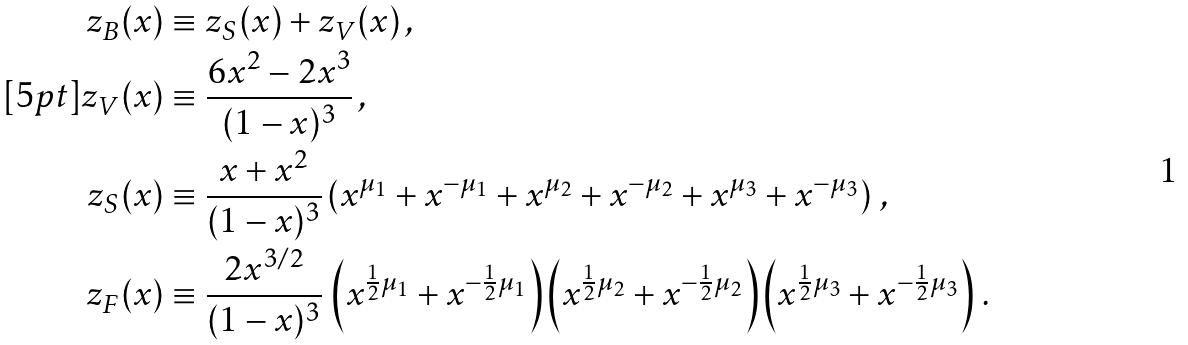Convert formula to latex. <formula><loc_0><loc_0><loc_500><loc_500>z _ { B } ( x ) & \equiv z _ { S } ( x ) + z _ { V } ( x ) \, , \\ [ 5 p t ] z _ { V } ( x ) & \equiv \frac { 6 x ^ { 2 } - 2 x ^ { 3 } } { ( 1 - x ) ^ { 3 } } \, , \\ z _ { S } ( x ) & \equiv \frac { x + x ^ { 2 } } { ( 1 - x ) ^ { 3 } } \left ( x ^ { \mu _ { 1 } } + x ^ { - \mu _ { 1 } } + x ^ { \mu _ { 2 } } + x ^ { - \mu _ { 2 } } + x ^ { \mu _ { 3 } } + x ^ { - \mu _ { 3 } } \right ) \, , \\ z _ { F } ( x ) & \equiv \frac { 2 x ^ { 3 / 2 } } { ( 1 - x ) ^ { 3 } } \, \left ( x ^ { \frac { 1 } { 2 } \mu _ { 1 } } + x ^ { - \frac { 1 } { 2 } \mu _ { 1 } } \right ) \left ( x ^ { \frac { 1 } { 2 } \mu _ { 2 } } + x ^ { - \frac { 1 } { 2 } \mu _ { 2 } } \right ) \left ( x ^ { \frac { 1 } { 2 } \mu _ { 3 } } + x ^ { - \frac { 1 } { 2 } \mu _ { 3 } } \right ) \, .</formula> 